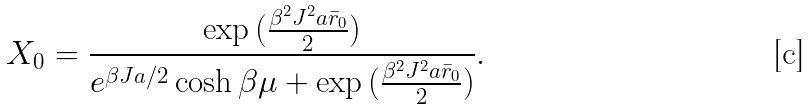Convert formula to latex. <formula><loc_0><loc_0><loc_500><loc_500>X _ { 0 } = \frac { \exp { ( \frac { \beta ^ { 2 } J ^ { 2 } a \bar { r } _ { 0 } } { 2 } ) } } { e ^ { \beta J a / 2 } \cosh \beta \mu + \exp { ( \frac { \beta ^ { 2 } J ^ { 2 } a \bar { r } _ { 0 } } { 2 } ) } } .</formula> 